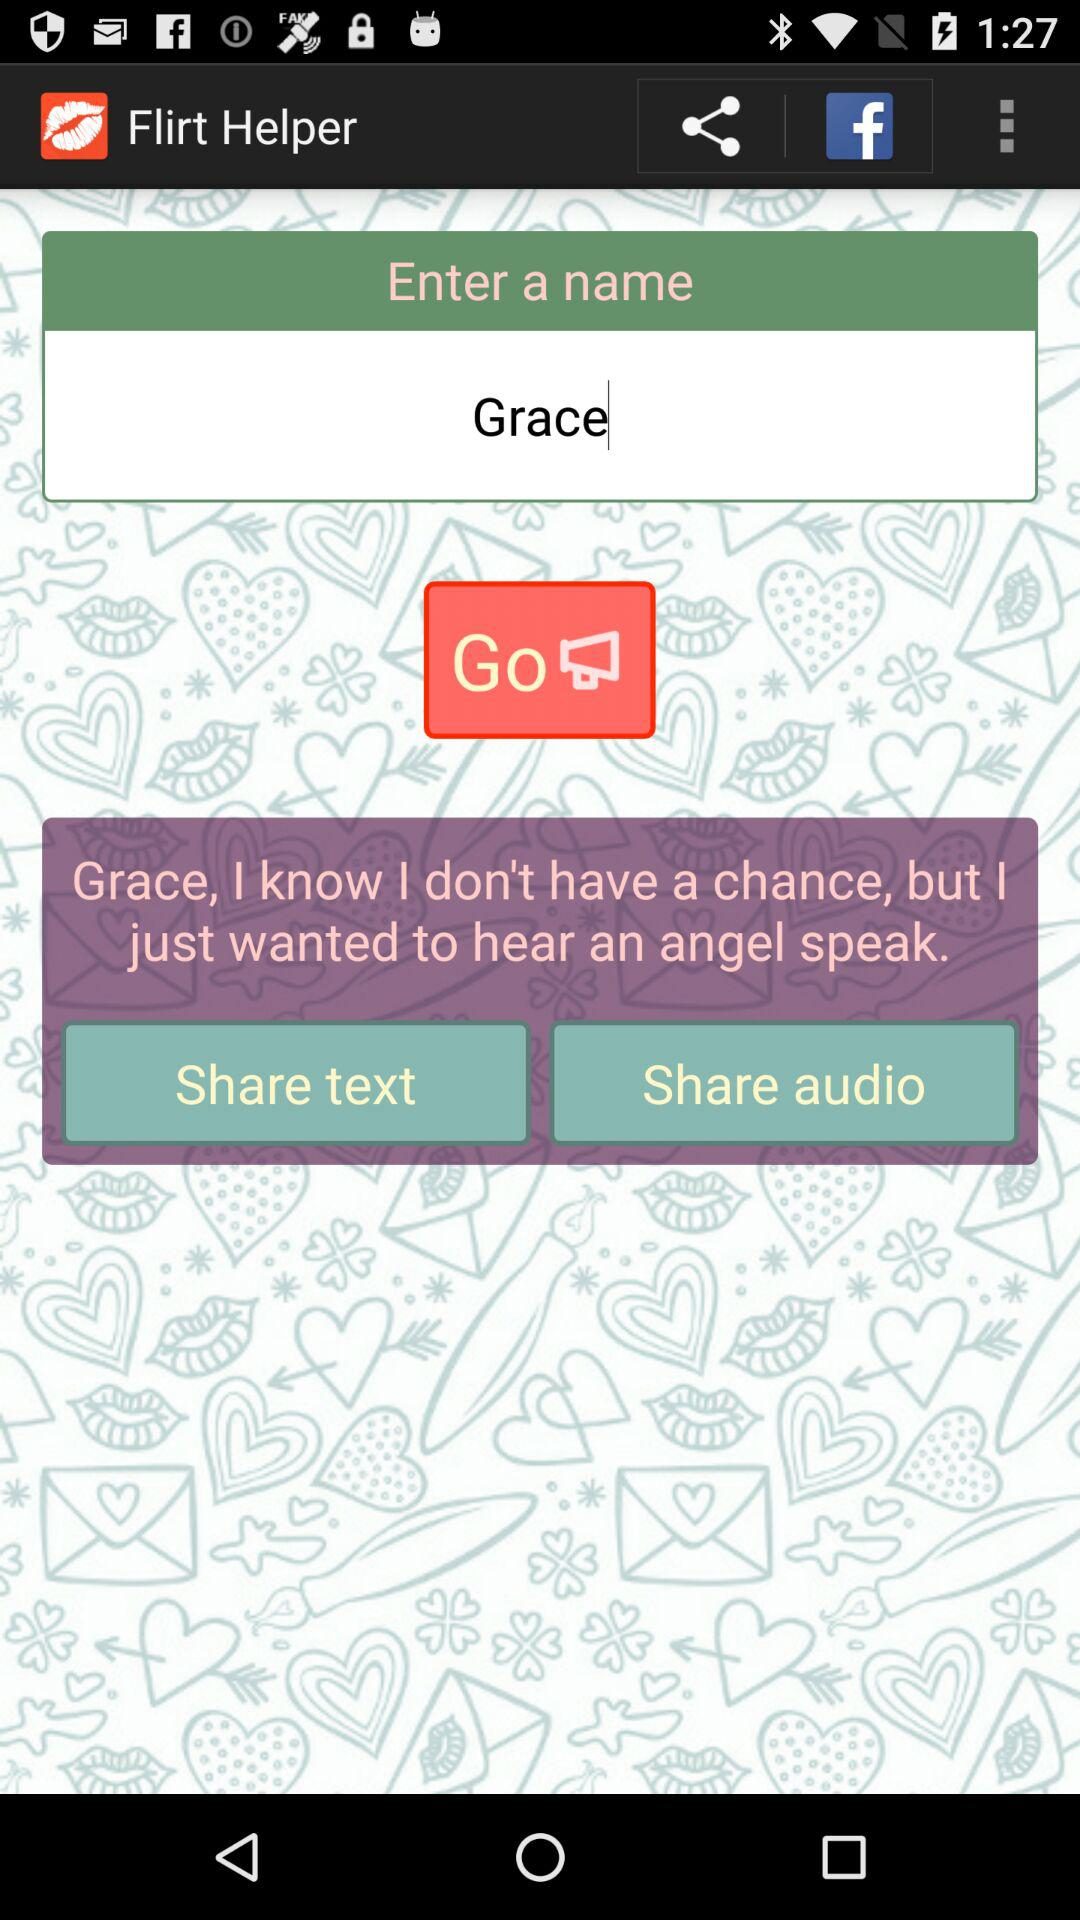What is the name of the app? The name of the app is "Flirt Helper". 